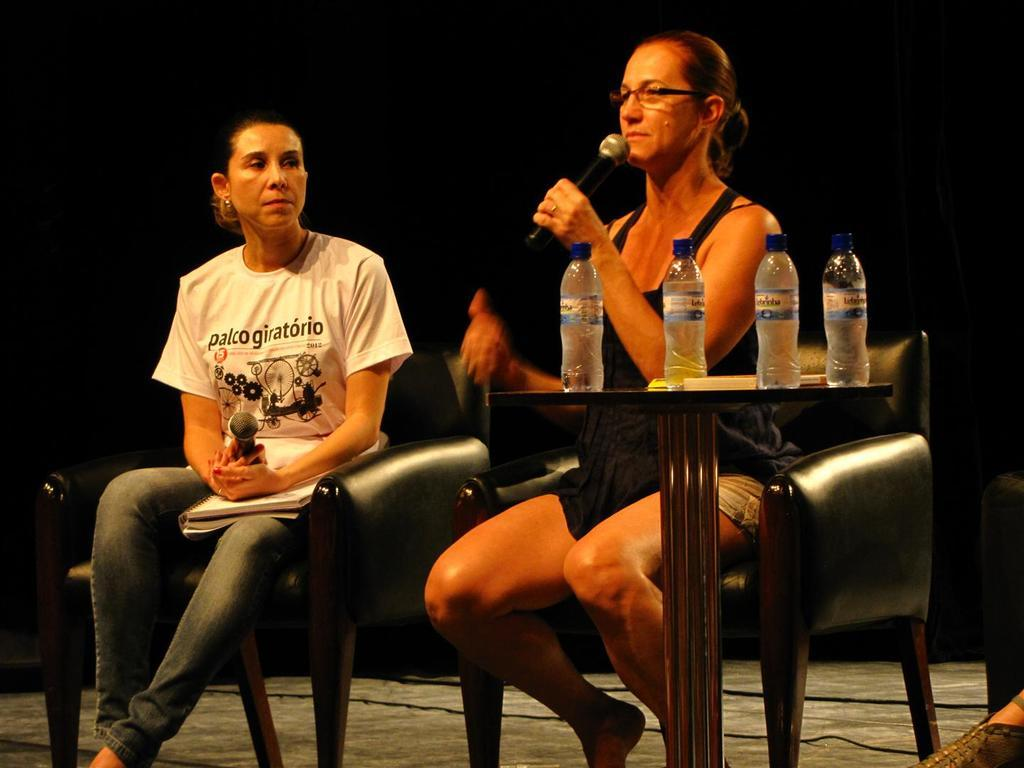How many people are in the image? There are two women in the image. What are the women doing in the image? The women are sitting on chairs. What can be seen on the table in the image? There are four bottles on a table in the image. What type of request is the judge making in the image? There is no judge present in the image, so no such request can be observed. 